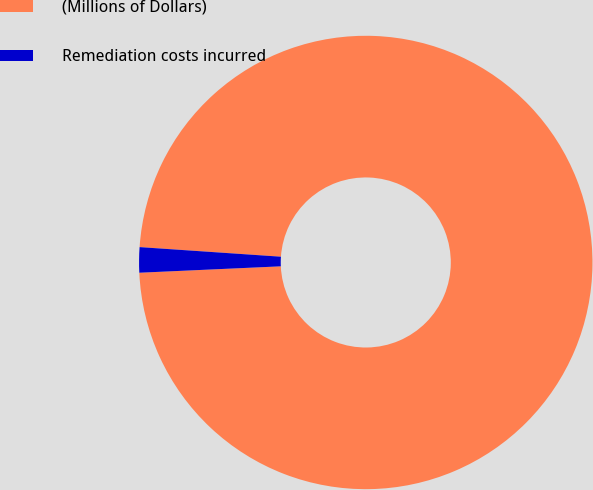Convert chart. <chart><loc_0><loc_0><loc_500><loc_500><pie_chart><fcel>(Millions of Dollars)<fcel>Remediation costs incurred<nl><fcel>98.2%<fcel>1.8%<nl></chart> 